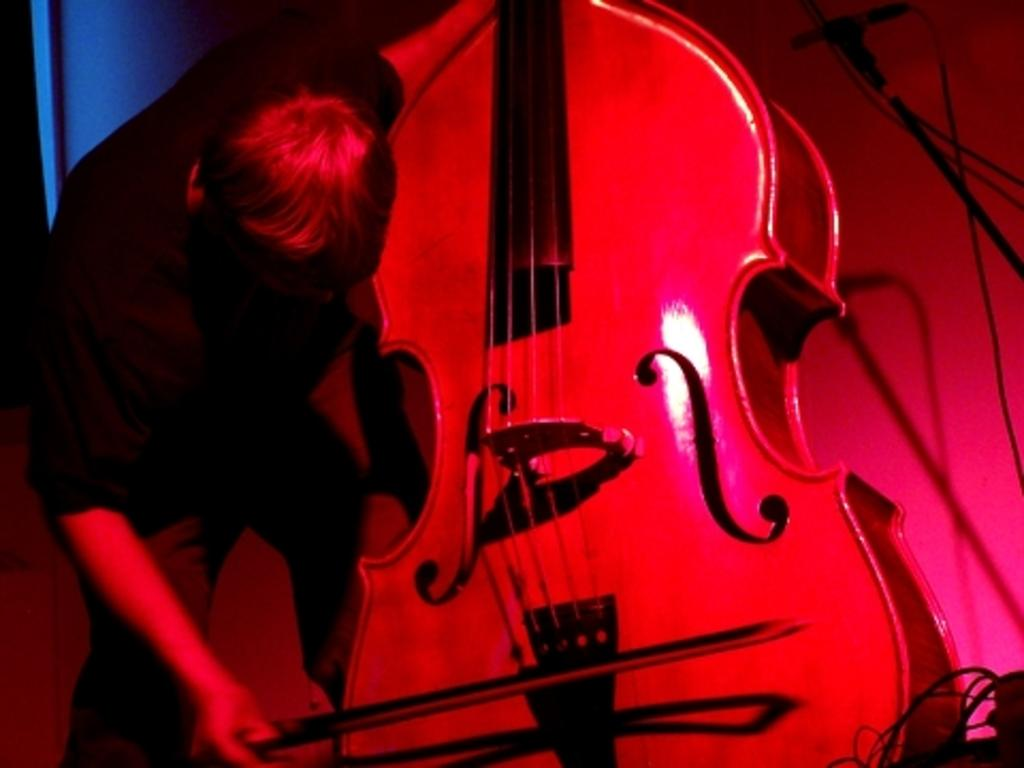What is the main subject of the image? There is a person in the image. What is the person doing in the image? The person is playing a guitar. How many snakes are wrapped around the guitar in the image? There are no snakes present in the image; the person is simply playing a guitar. What advice might the person's grandmother give them about playing the guitar in the image? There is no mention of a grandmother or any advice in the image, as it only shows a person playing a guitar. 